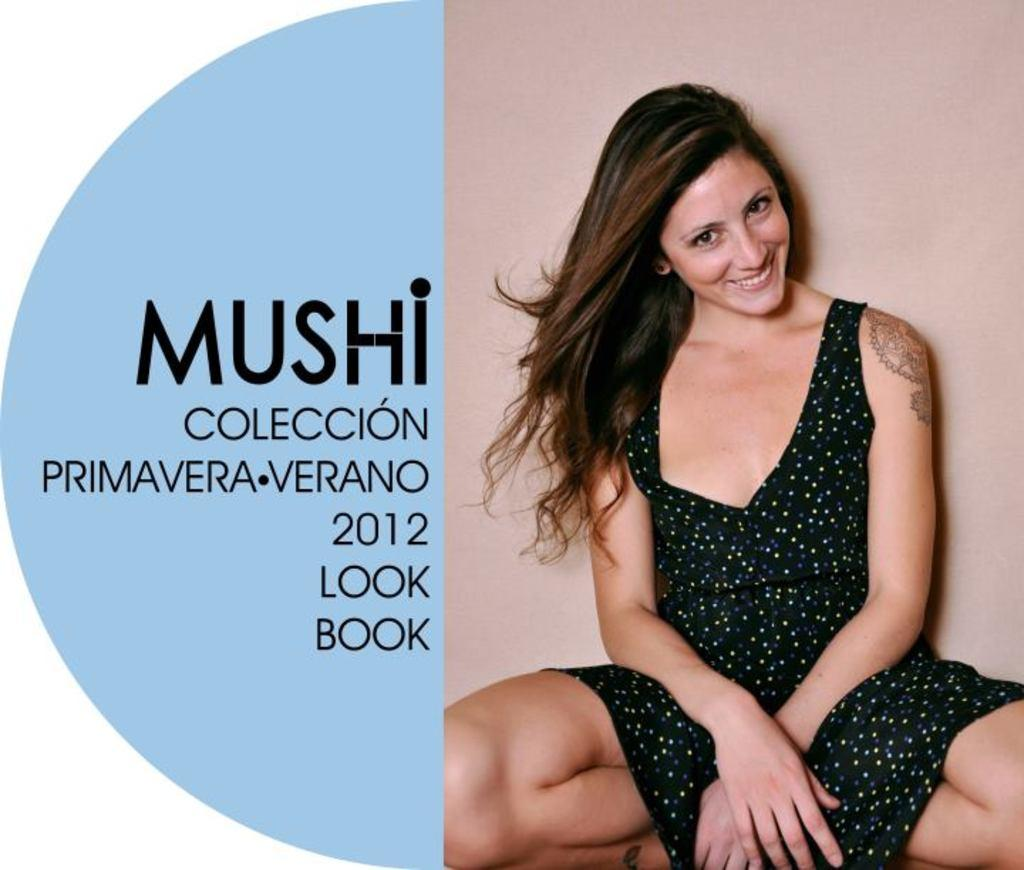What is the person in the image doing? There is a person sitting in the image. What is the person wearing? The person is wearing a black dress. Can you describe any text or writing in the image? There is some writing visible in the image, and it is in black color. What type of force is being applied to the person in the image? There is no force being applied to the person in the image; they are simply sitting. 